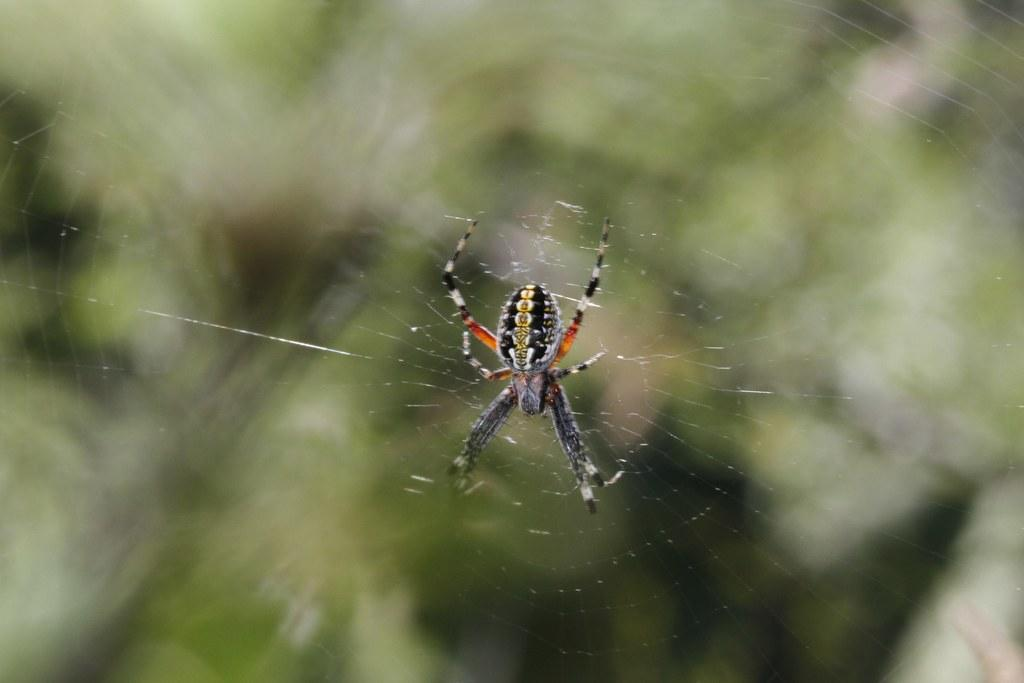What is the main subject of the image? There is a spider in the image. Where is the spider located? The spider is in a web. What is the opinion of the desk about the airplane in the image? There is no desk or airplane present in the image, so it is not possible to determine any opinions. 